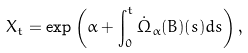<formula> <loc_0><loc_0><loc_500><loc_500>X _ { t } = \exp \left ( \alpha + \int _ { 0 } ^ { t } \dot { \Omega } _ { \alpha } ( B ) ( s ) d s \right ) ,</formula> 